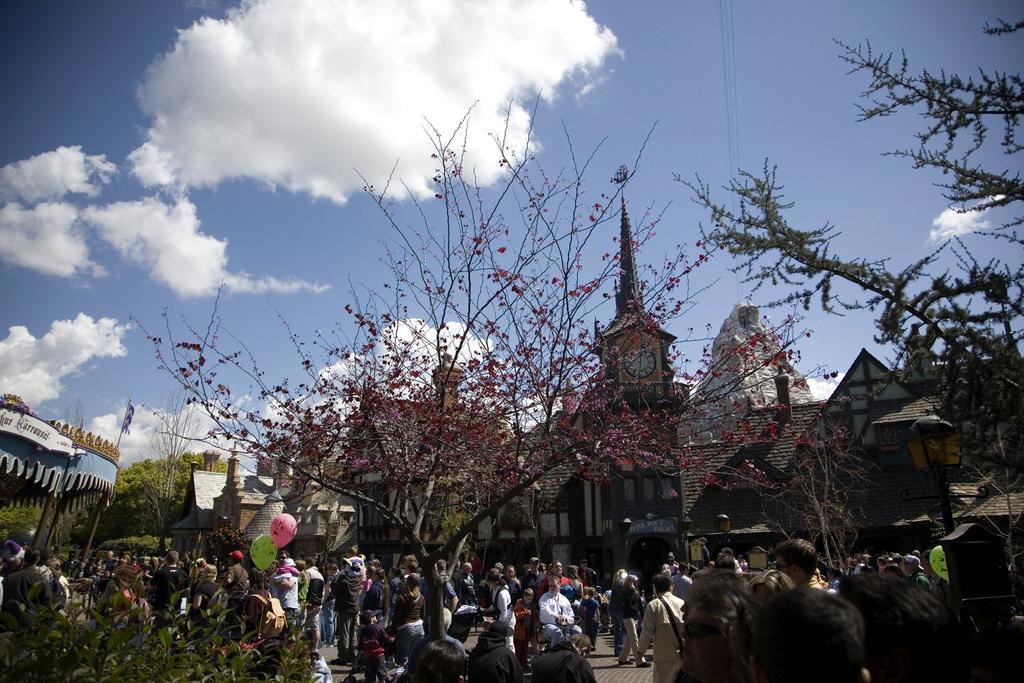Could you give a brief overview of what you see in this image? In the background we can see the clouds in the sky. In this picture we can see the trees, transmission wires, buildings, clock on the wall. We can see the balloons, green leaves, people and few objects. On the left side of the picture we can see a tent, poles and there is something written. 